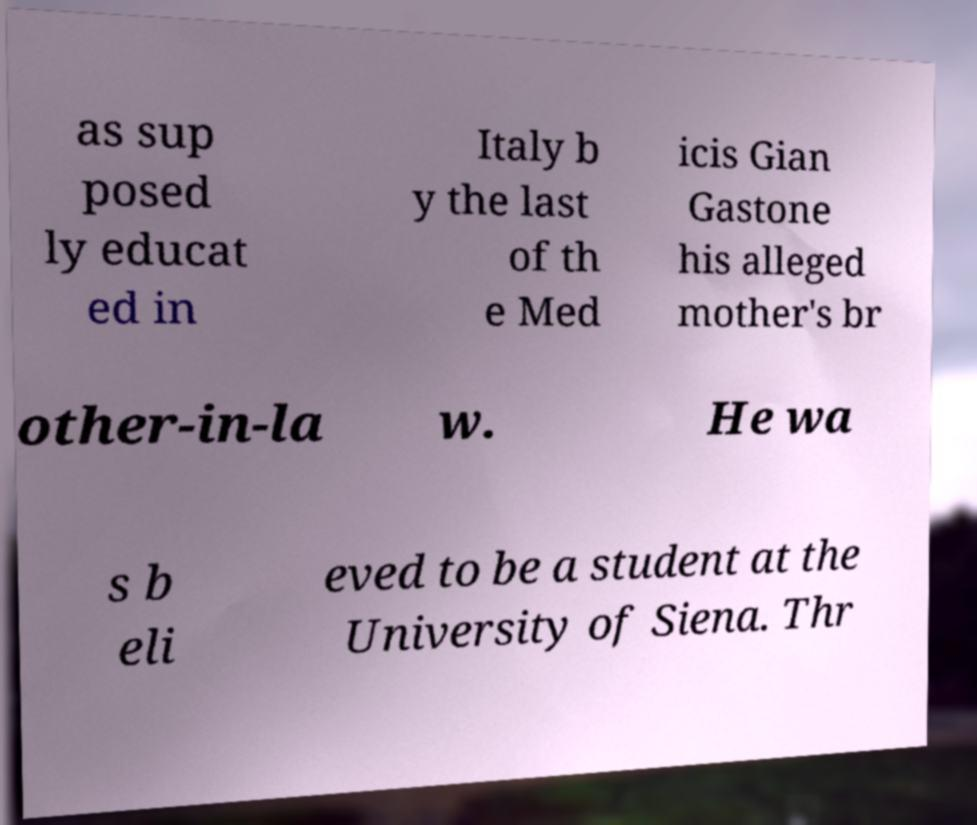Please read and relay the text visible in this image. What does it say? as sup posed ly educat ed in Italy b y the last of th e Med icis Gian Gastone his alleged mother's br other-in-la w. He wa s b eli eved to be a student at the University of Siena. Thr 